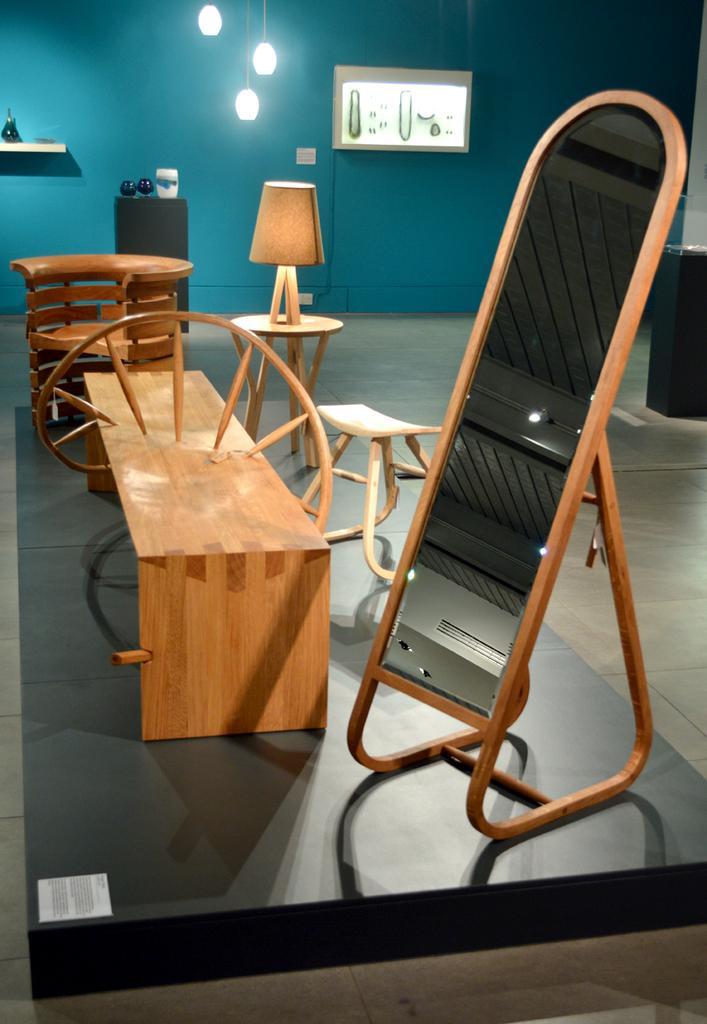Please provide a concise description of this image. In this picture I can see a wooden table, wooden bench and some other wooden objects on the floor. In the background I can see a blue color wall, lights and some other objects attached to the wall. 